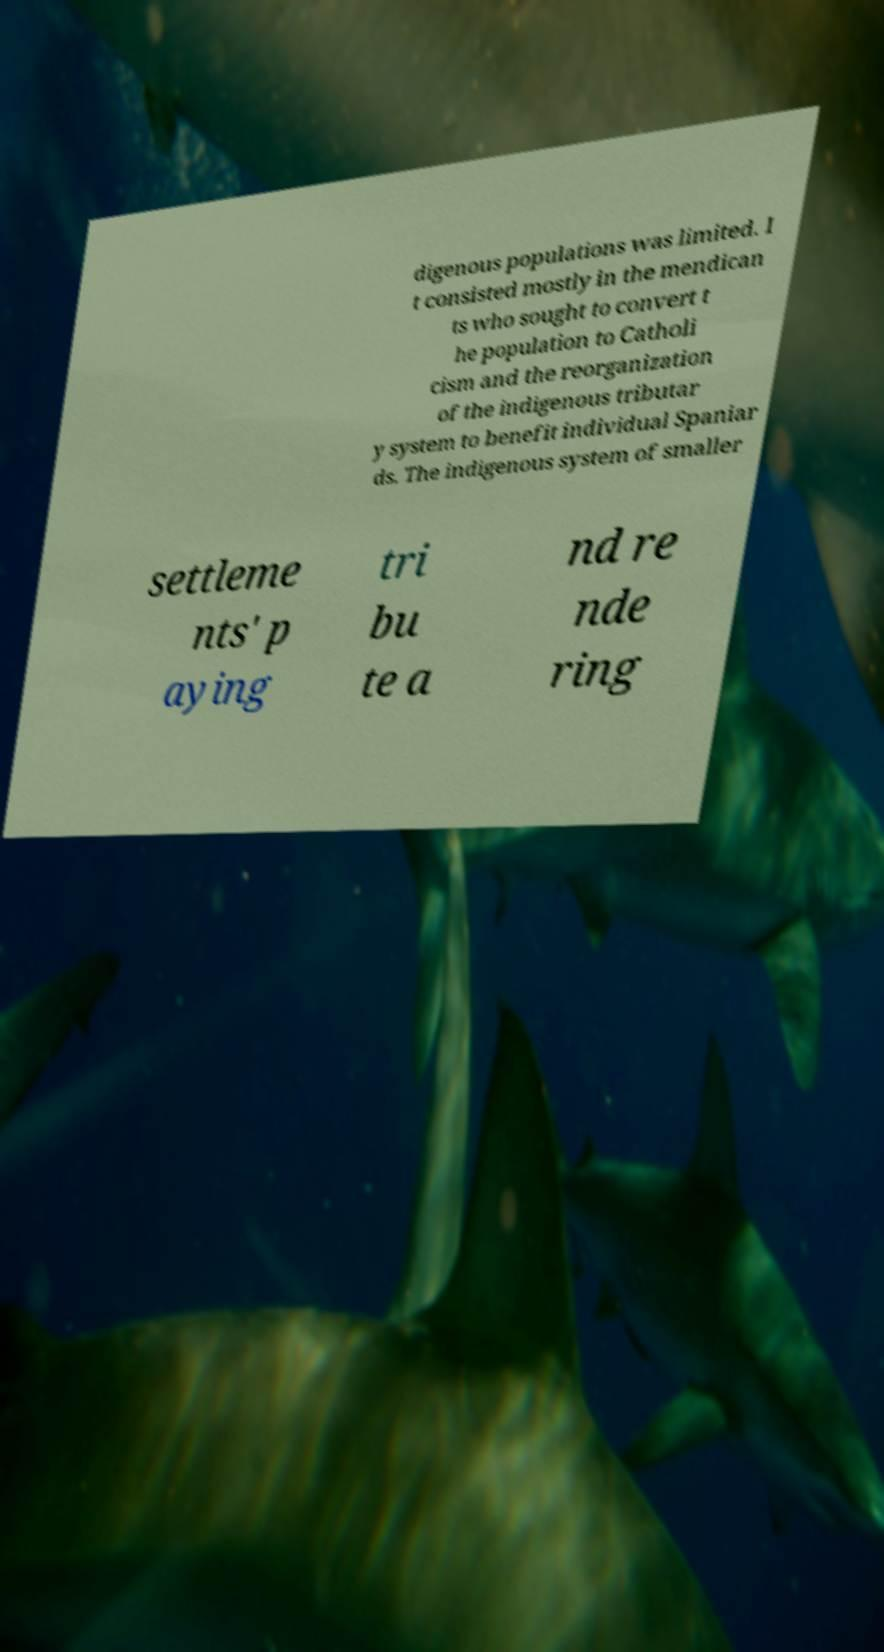Could you extract and type out the text from this image? digenous populations was limited. I t consisted mostly in the mendican ts who sought to convert t he population to Catholi cism and the reorganization of the indigenous tributar y system to benefit individual Spaniar ds. The indigenous system of smaller settleme nts' p aying tri bu te a nd re nde ring 